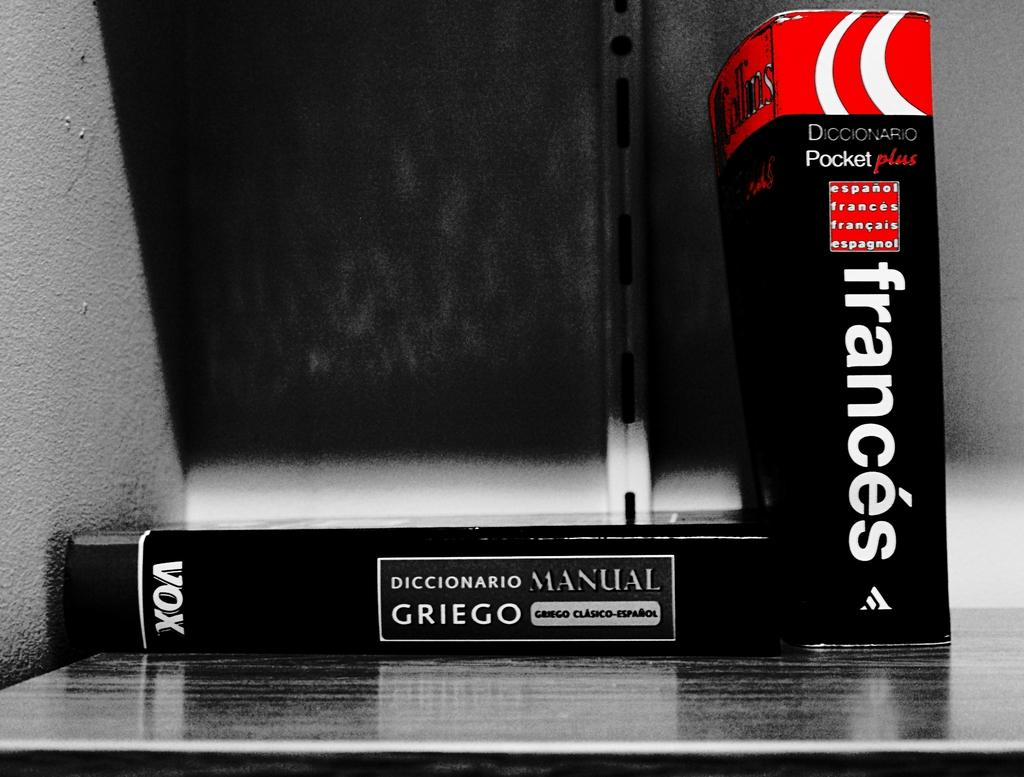Who published the book?
Your answer should be compact. Vox. 